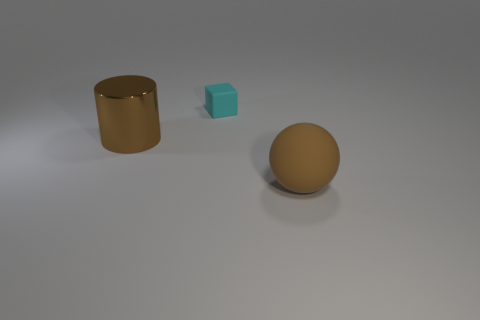What time of day does the lighting in the image suggest? The soft shadows and neutral lighting suggest an interior setting with artificial light sources, likely irrespective of the time of day outside. 